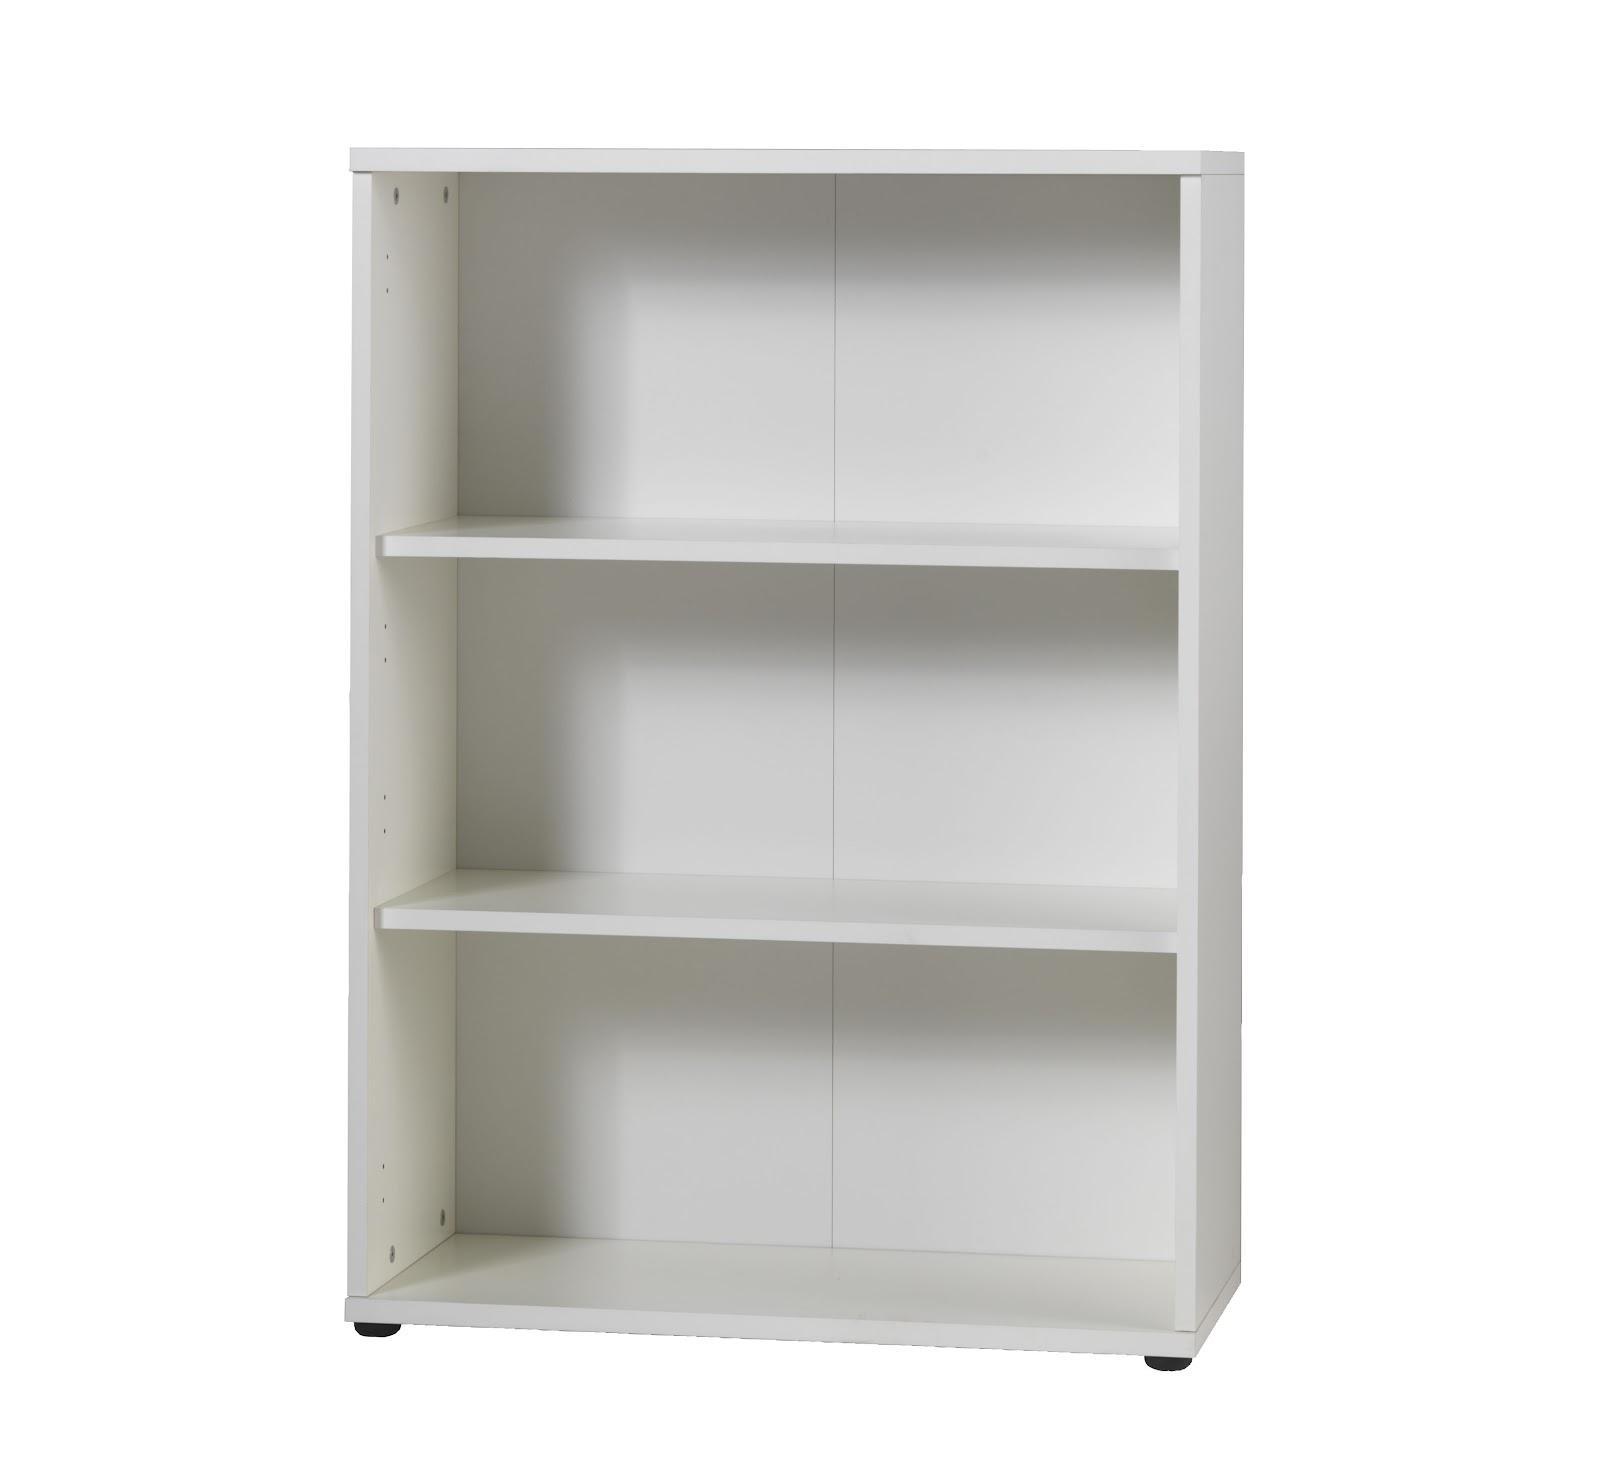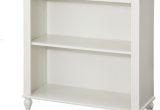The first image is the image on the left, the second image is the image on the right. For the images shown, is this caption "Two boxy white bookcases are different sizes, one of them with exactly three shelves and the other with two." true? Answer yes or no. Yes. The first image is the image on the left, the second image is the image on the right. Examine the images to the left and right. Is the description "In the left image, there's a bookcase with a single shelf angled toward the right." accurate? Answer yes or no. No. 